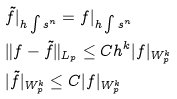Convert formula to latex. <formula><loc_0><loc_0><loc_500><loc_500>& \tilde { f } | _ { h \int s ^ { n } } = f | _ { h \int s ^ { n } } \\ & \| f - \tilde { f } \| _ { L _ { p } } \leq C h ^ { k } | f | _ { W _ { p } ^ { k } } \\ & | \tilde { f } | _ { W _ { p } ^ { k } } \leq C | f | _ { W _ { p } ^ { k } }</formula> 